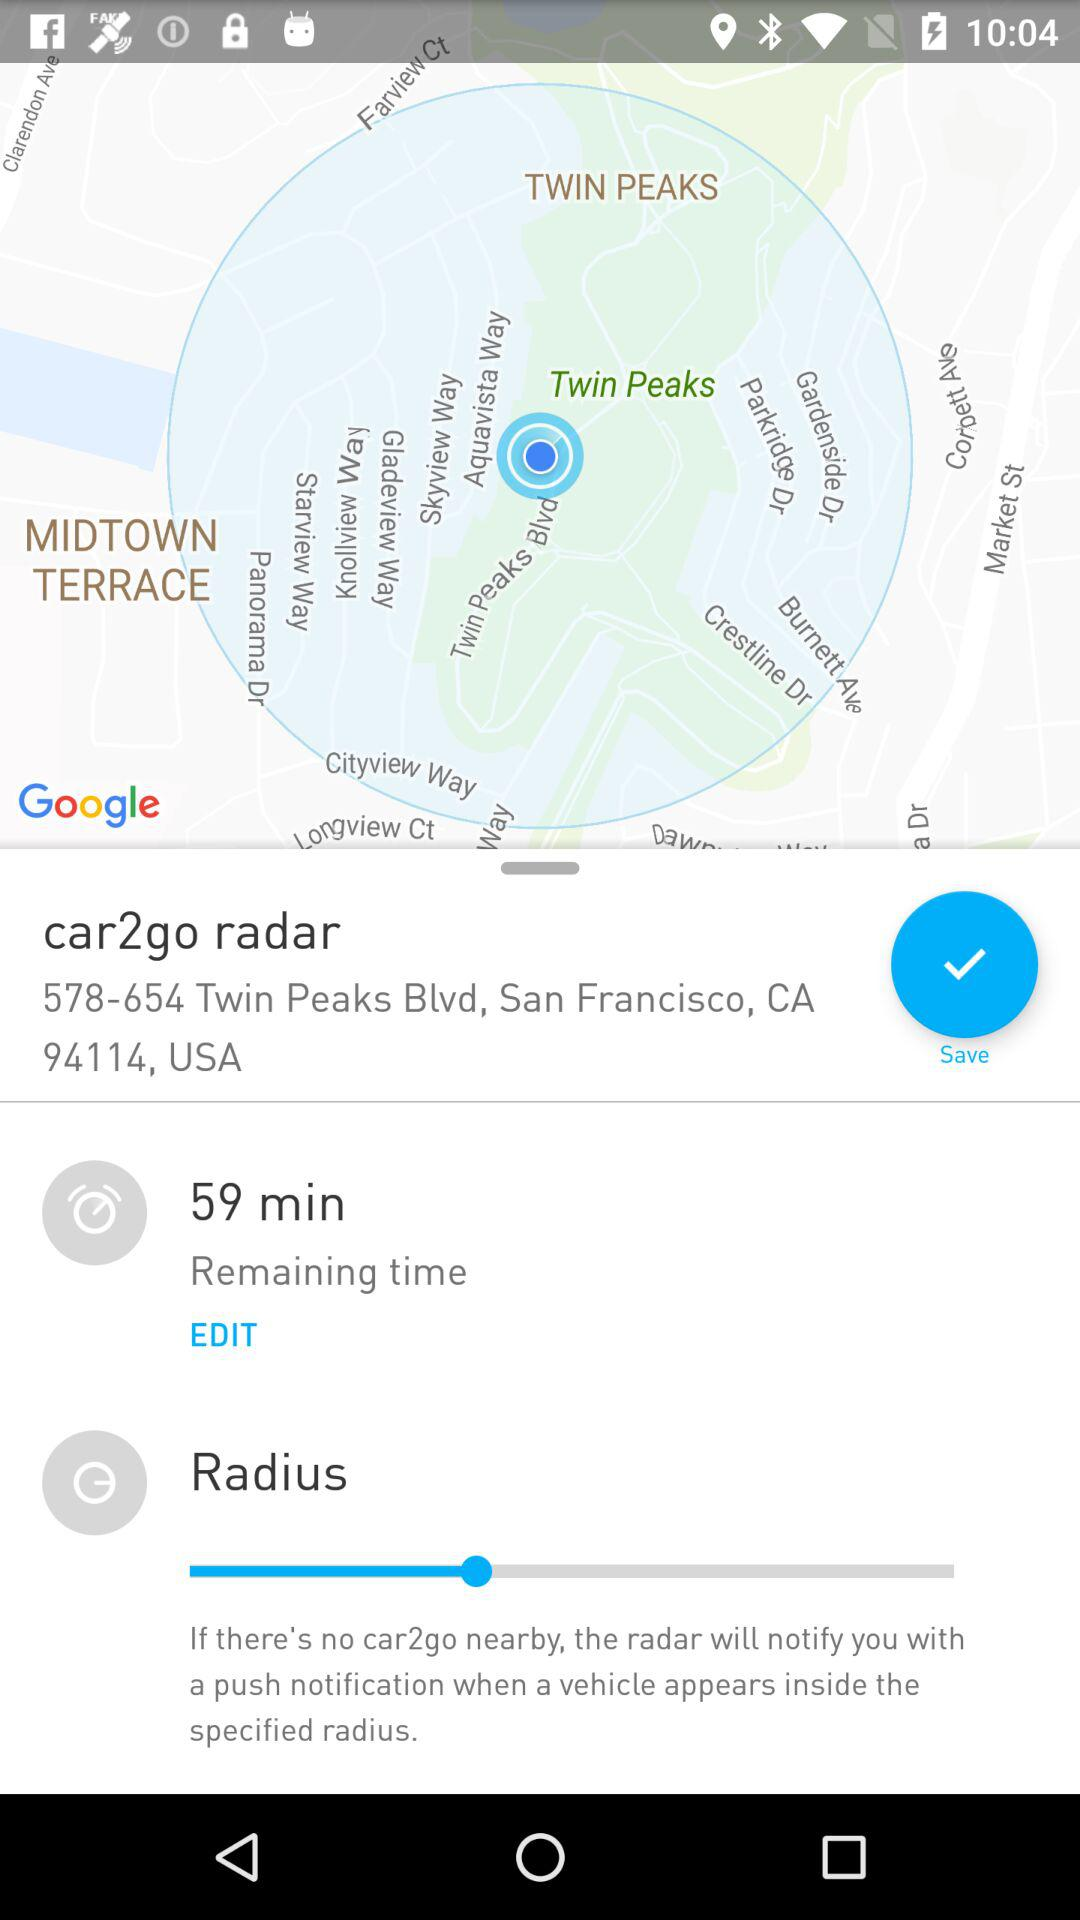What is the name of the application? The name of the application is "car2go". 